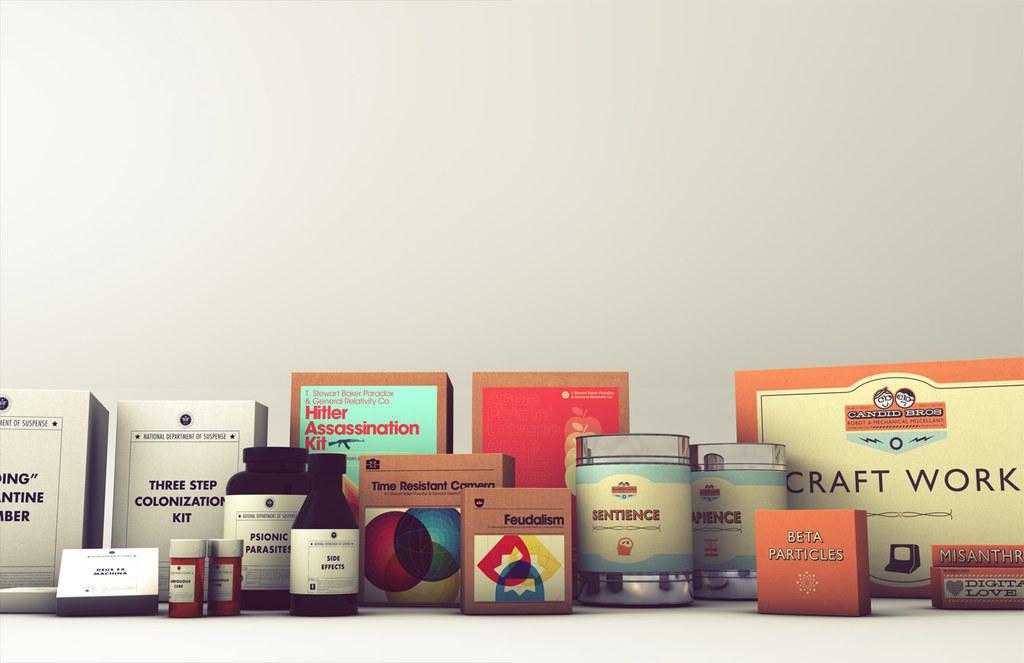What sort of work is printed on the box on the right?
Your answer should be very brief. Craft work. 